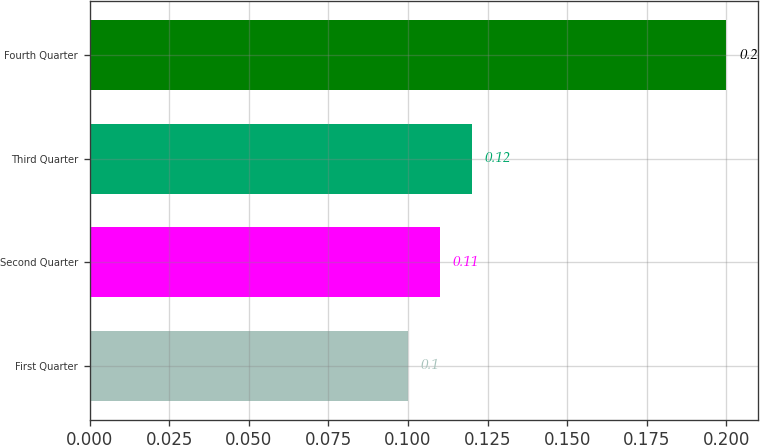Convert chart. <chart><loc_0><loc_0><loc_500><loc_500><bar_chart><fcel>First Quarter<fcel>Second Quarter<fcel>Third Quarter<fcel>Fourth Quarter<nl><fcel>0.1<fcel>0.11<fcel>0.12<fcel>0.2<nl></chart> 